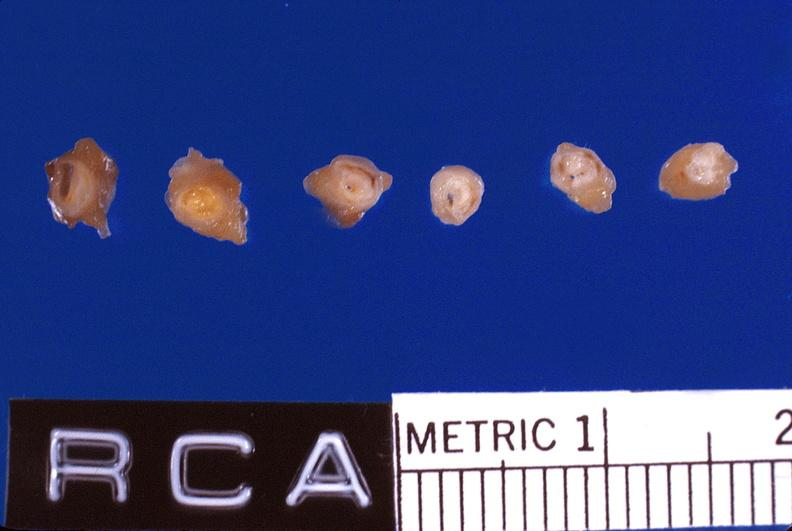what does this image show?
Answer the question using a single word or phrase. Atherosclerosis 